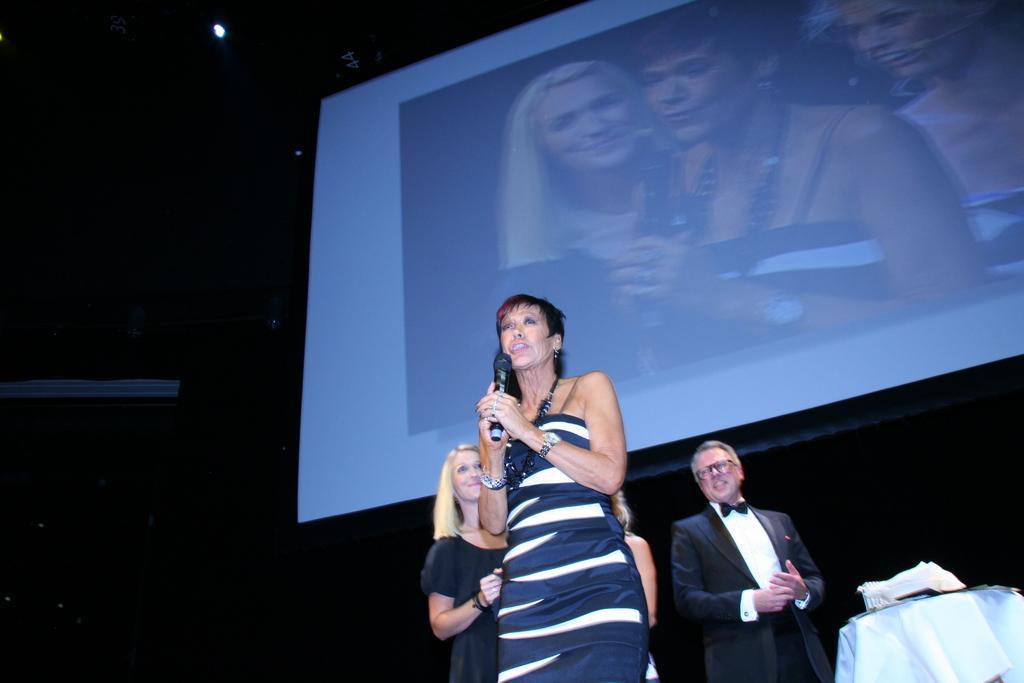In one or two sentences, can you explain what this image depicts? In this image I can see a woman is standing and speaking in the microphone, on the right side a man is standing, he wore a coat, shirt. In the middle there is a projector screen. 